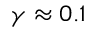Convert formula to latex. <formula><loc_0><loc_0><loc_500><loc_500>\gamma \approx 0 . 1</formula> 